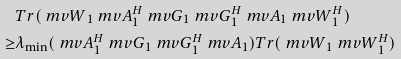Convert formula to latex. <formula><loc_0><loc_0><loc_500><loc_500>& T r ( { \ m v W } _ { 1 } { \ m v A } ^ { H } _ { 1 } { \ m v G } _ { 1 } { \ m v G } _ { 1 } ^ { H } { \ m v A } _ { 1 } { \ m v W } _ { 1 } ^ { H } ) \\ \geq & \lambda _ { \min } ( { \ m v A } ^ { H } _ { 1 } { \ m v G } _ { 1 } { \ m v G } _ { 1 } ^ { H } { \ m v A } _ { 1 } ) T r ( { \ m v W } _ { 1 } { \ m v W } _ { 1 } ^ { H } )</formula> 